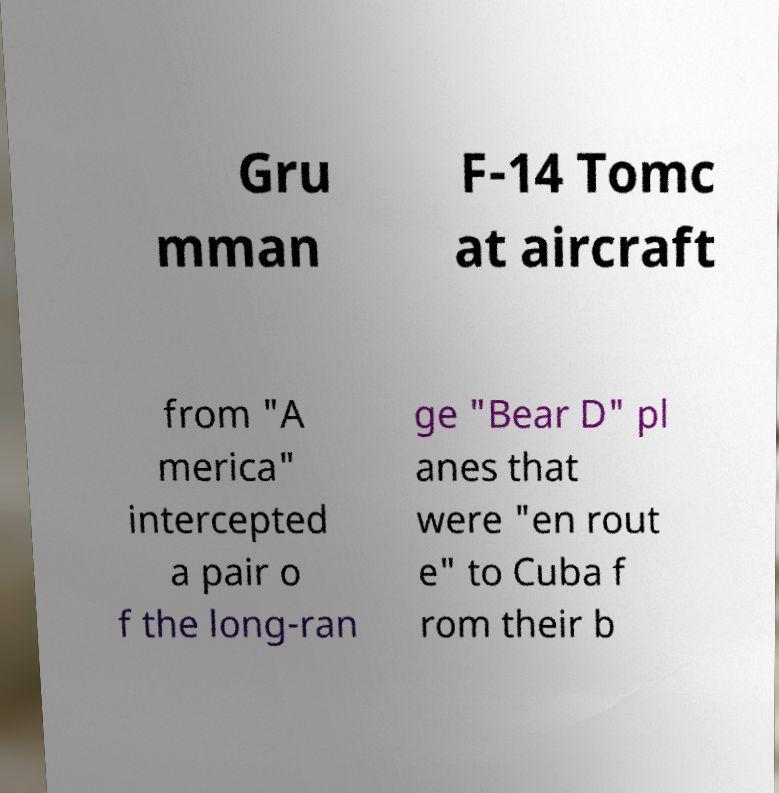I need the written content from this picture converted into text. Can you do that? Gru mman F-14 Tomc at aircraft from "A merica" intercepted a pair o f the long-ran ge "Bear D" pl anes that were "en rout e" to Cuba f rom their b 